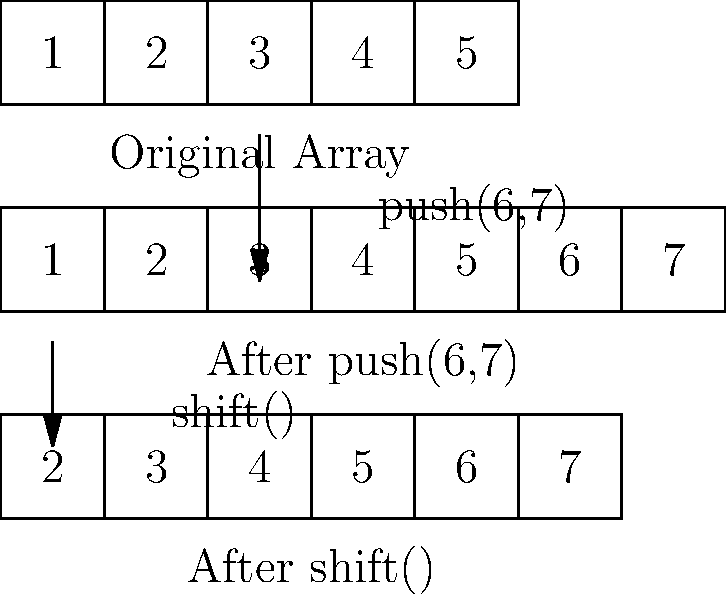Given the following Ruby array operations:

```ruby
arr = [1, 2, 3, 4, 5]
arr.push(6, 7)
first_element = arr.shift()
```

What is the value of `first_element` and what does the `arr` look like after these operations? Let's break down the operations step by step:

1. Initial array:
   `arr = [1, 2, 3, 4, 5]`

2. After `arr.push(6, 7)`:
   - The `push` method adds elements to the end of the array.
   - Two elements, 6 and 7, are added.
   - The array becomes `[1, 2, 3, 4, 5, 6, 7]`

3. `first_element = arr.shift()`:
   - The `shift` method removes and returns the first element of the array.
   - The first element (1) is removed and assigned to `first_element`.
   - The array becomes `[2, 3, 4, 5, 6, 7]`

Therefore:
- `first_element` is assigned the value 1
- The final state of `arr` is `[2, 3, 4, 5, 6, 7]`
Answer: first_element = 1, arr = [2, 3, 4, 5, 6, 7] 